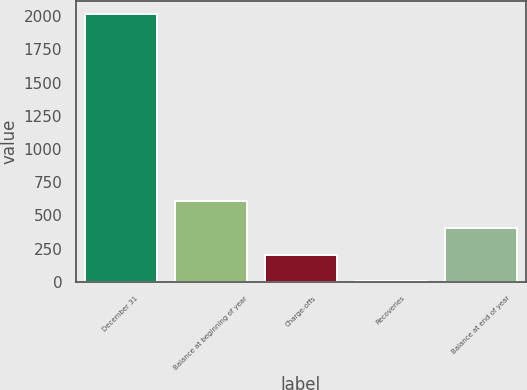Convert chart to OTSL. <chart><loc_0><loc_0><loc_500><loc_500><bar_chart><fcel>December 31<fcel>Balance at beginning of year<fcel>Charge-offs<fcel>Recoveries<fcel>Balance at end of year<nl><fcel>2014<fcel>606.3<fcel>204.1<fcel>3<fcel>405.2<nl></chart> 